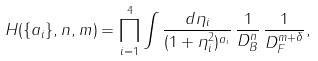<formula> <loc_0><loc_0><loc_500><loc_500>H ( \{ a _ { i } \} , n , m ) = \prod _ { i = 1 } ^ { 4 } \int \frac { d \eta _ { i } } { ( 1 + \eta _ { i } ^ { 2 } ) ^ { a _ { i } } } \, \frac { 1 } { D _ { B } ^ { n } } \, \frac { 1 } { D _ { F } ^ { m + \delta } } ,</formula> 